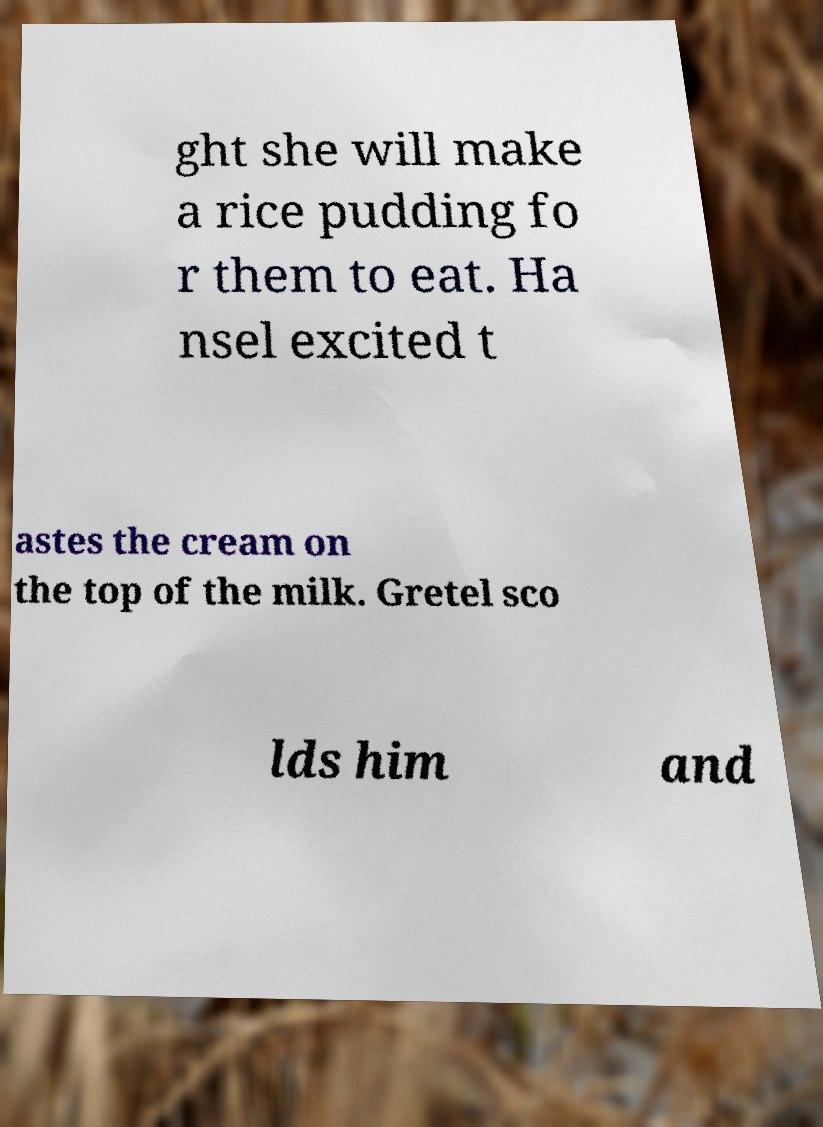I need the written content from this picture converted into text. Can you do that? ght she will make a rice pudding fo r them to eat. Ha nsel excited t astes the cream on the top of the milk. Gretel sco lds him and 